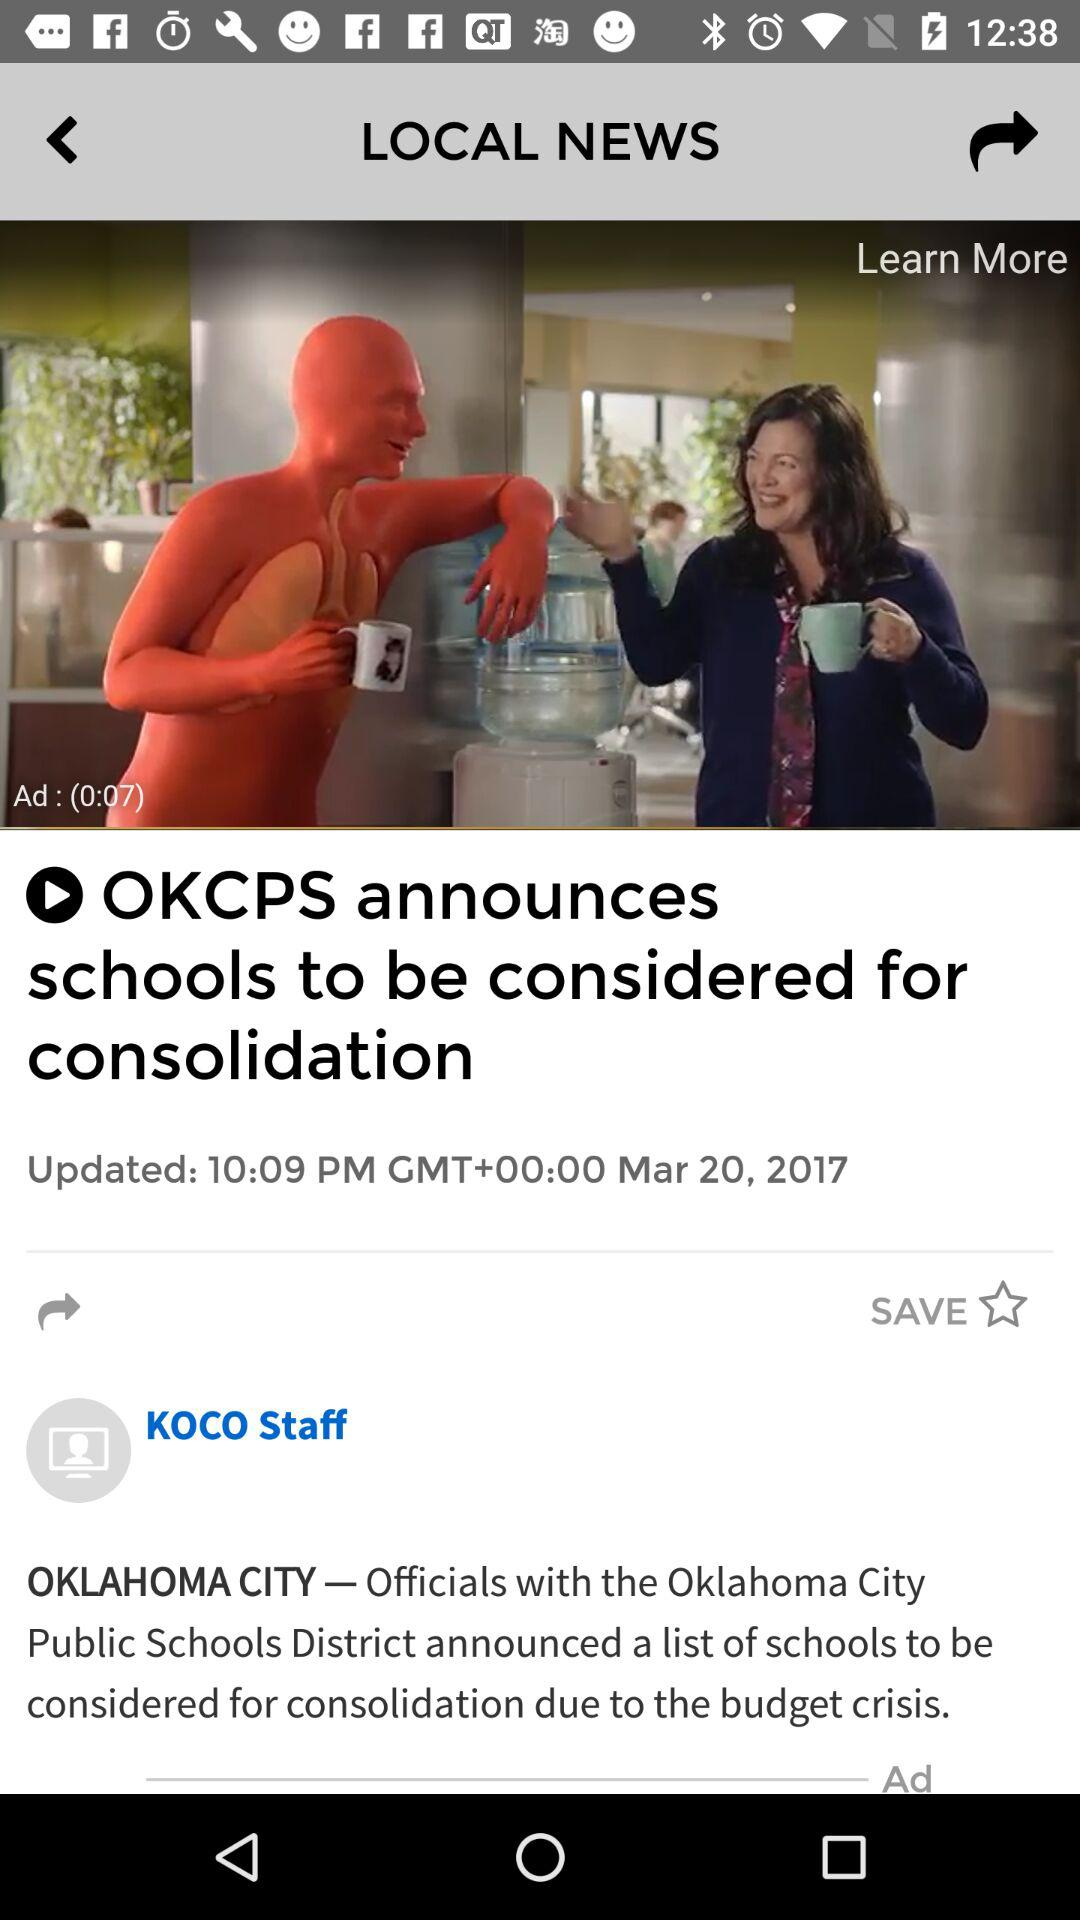When did the news get updated? The news got updated on March 20, 2017 at 10:09 PM. 